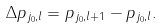<formula> <loc_0><loc_0><loc_500><loc_500>\Delta p _ { j _ { 0 } , l } = p _ { j _ { 0 } , l + 1 } - p _ { j _ { 0 } , l } .</formula> 